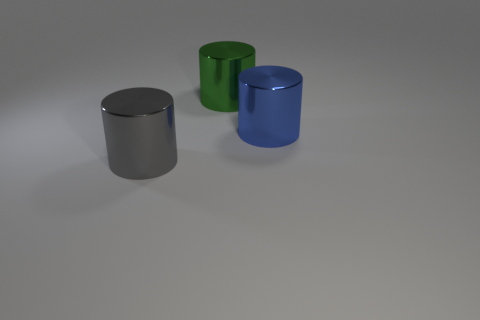How does the lighting affect the appearance of these objects? The lighting in the image seems to be coming from above, casting soft shadows on the ground and emphasizing the shininess and the three-dimensional form of each cylinder. It gives the scene a calm and almost studio-like quality. Does the lighting suggest anything about the setting or time of day? Given the neutral background and the controlled, soft shadows, it's likely that these cylinders are not in a natural setting. Instead, they're probably displayed in a controlled environment like a studio, with artificial lighting that doesn't indicate a specific time of day. 